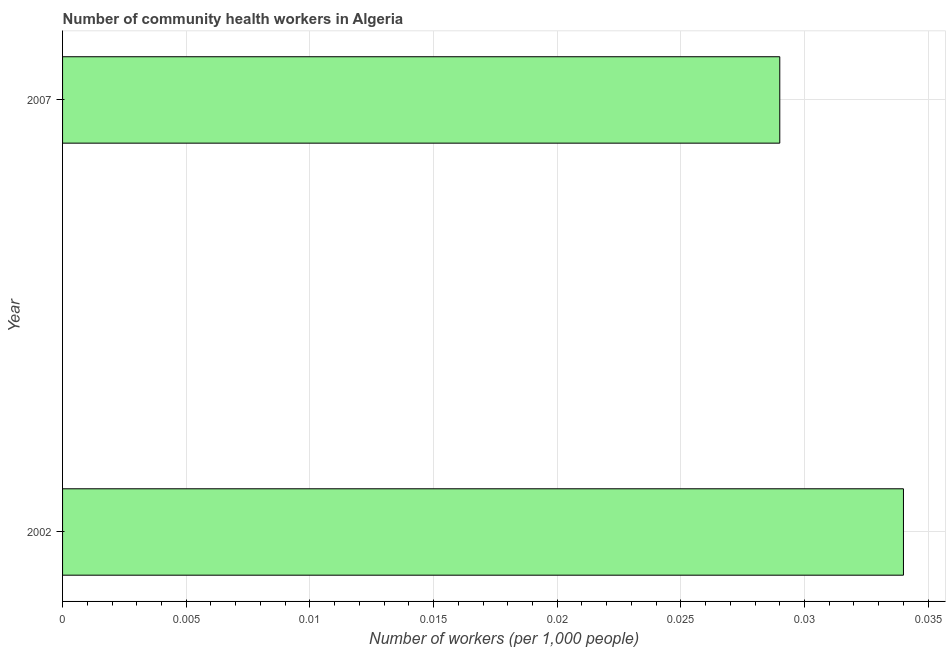Does the graph contain any zero values?
Offer a very short reply. No. What is the title of the graph?
Ensure brevity in your answer.  Number of community health workers in Algeria. What is the label or title of the X-axis?
Give a very brief answer. Number of workers (per 1,0 people). What is the number of community health workers in 2007?
Provide a short and direct response. 0.03. Across all years, what is the maximum number of community health workers?
Offer a very short reply. 0.03. Across all years, what is the minimum number of community health workers?
Keep it short and to the point. 0.03. In which year was the number of community health workers maximum?
Give a very brief answer. 2002. What is the sum of the number of community health workers?
Provide a succinct answer. 0.06. What is the difference between the number of community health workers in 2002 and 2007?
Ensure brevity in your answer.  0.01. What is the average number of community health workers per year?
Your answer should be compact. 0.03. What is the median number of community health workers?
Make the answer very short. 0.03. Do a majority of the years between 2002 and 2007 (inclusive) have number of community health workers greater than 0.011 ?
Provide a succinct answer. Yes. What is the ratio of the number of community health workers in 2002 to that in 2007?
Offer a very short reply. 1.17. What is the difference between two consecutive major ticks on the X-axis?
Your answer should be compact. 0.01. Are the values on the major ticks of X-axis written in scientific E-notation?
Keep it short and to the point. No. What is the Number of workers (per 1,000 people) in 2002?
Offer a terse response. 0.03. What is the Number of workers (per 1,000 people) in 2007?
Make the answer very short. 0.03. What is the difference between the Number of workers (per 1,000 people) in 2002 and 2007?
Offer a very short reply. 0.01. What is the ratio of the Number of workers (per 1,000 people) in 2002 to that in 2007?
Provide a succinct answer. 1.17. 